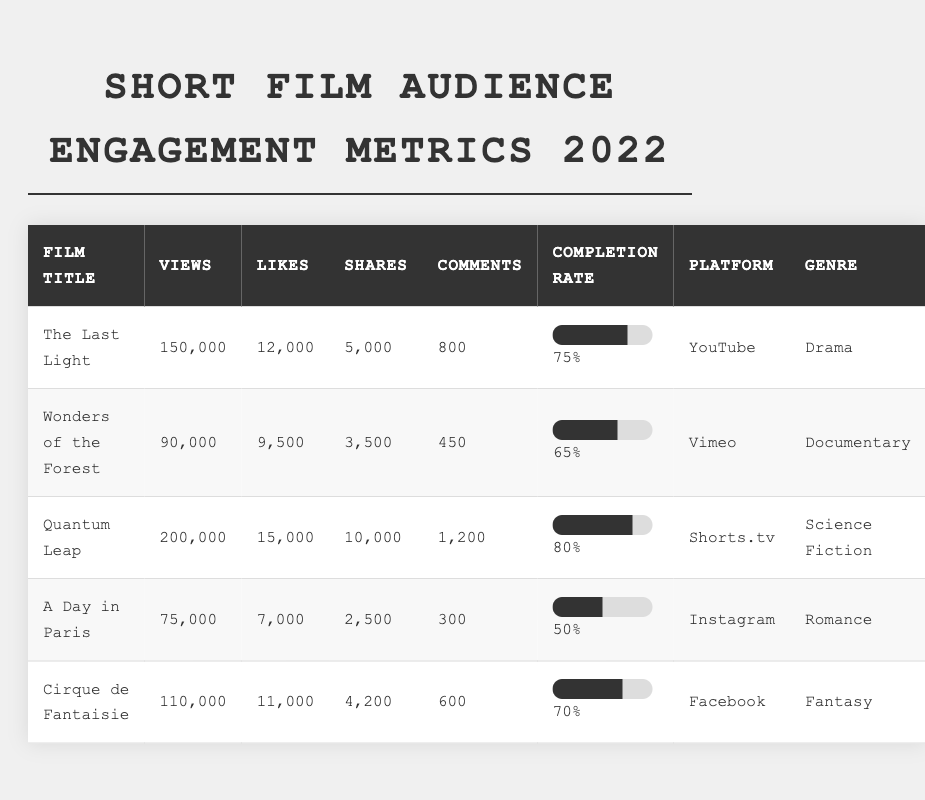What is the highest number of views for a short film in the table? The film with the highest number of views is "Quantum Leap" with a total of 200,000 views.
Answer: 200,000 Which film has the most likes? "Quantum Leap" has the most likes, totaling 15,000 likes.
Answer: 15,000 What is the completion rate for "A Day in Paris"? The completion rate for "A Day in Paris" as shown in the table is 50%.
Answer: 50% How many comments did "Wonders of the Forest" receive? The film "Wonders of the Forest" received 450 comments, which is directly stated in the table.
Answer: 450 Which genre received the most shares overall? To find the genre with the most shares, I sum the shares for each genre: Drama (5,000), Documentary (3,500), Science Fiction (10,000), Romance (2,500), and Fantasy (4,200). The total shares for Science Fiction is the highest at 10,000.
Answer: Science Fiction What percentage of films had a completion rate higher than 70%? The films with a completion rate higher than 70% are "The Last Light" (75%) and "Quantum Leap" (80%). That's 2 out of 5 films, which translates to (2/5)*100 = 40%.
Answer: 40% Did "Cirque de Fantaisie" have more likes than "A Day in Paris"? Yes, "Cirque de Fantaisie" had 11,000 likes, which is greater than the 7,000 likes received by "A Day in Paris."
Answer: Yes What is the average number of shares for documentaries in the table? The only documentary is "Wonders of the Forest," which has 3,500 shares. Since it's the only data point, the average is 3,500.
Answer: 3,500 Which film had the lowest views and what was that value? "A Day in Paris" had the lowest views with a total of 75,000 views, confirmed by looking at the views column.
Answer: 75,000 How many total views were recorded across all the films? I sum the views for each film: 150,000 (The Last Light) + 90,000 (Wonders of the Forest) + 200,000 (Quantum Leap) + 75,000 (A Day in Paris) + 110,000 (Cirque de Fantaisie) = 625,000 total views.
Answer: 625,000 Which release platform had the film with the highest completion rate? "Quantum Leap" on Shorts.tv has the highest completion rate of 80%. It can be found in the completion rate column.
Answer: Shorts.tv 